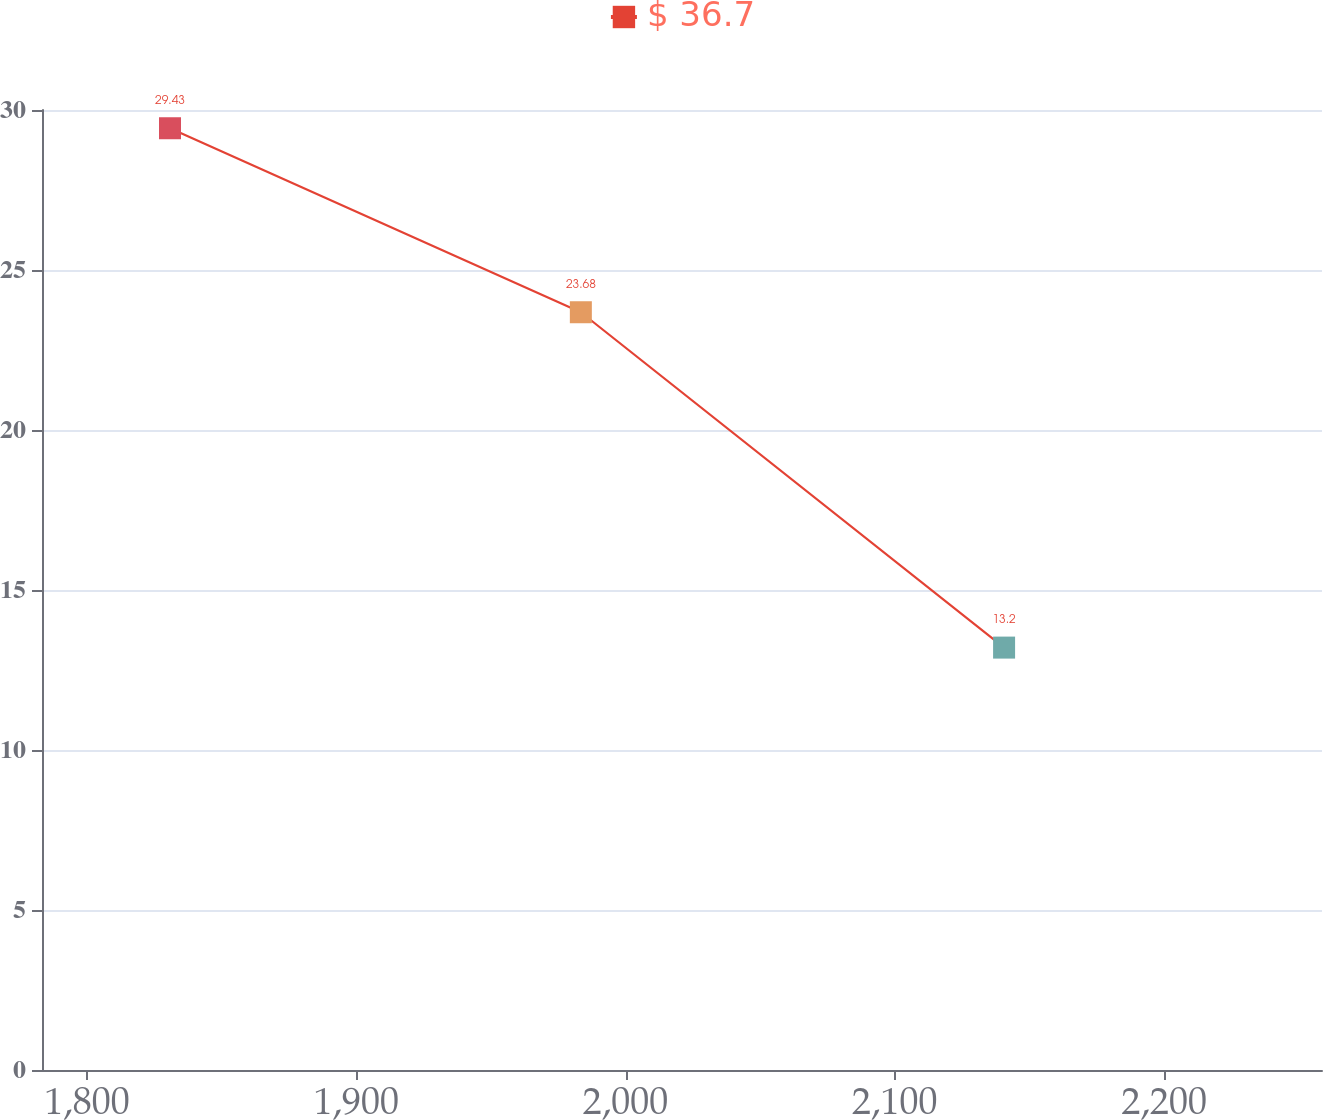Convert chart. <chart><loc_0><loc_0><loc_500><loc_500><line_chart><ecel><fcel>$ 36.7<nl><fcel>1830.84<fcel>29.43<nl><fcel>1983.4<fcel>23.68<nl><fcel>2140.56<fcel>13.2<nl><fcel>2306.14<fcel>11.4<nl></chart> 